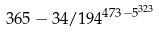Convert formula to latex. <formula><loc_0><loc_0><loc_500><loc_500>3 6 5 - 3 4 / 1 9 4 ^ { 4 7 3 - 5 ^ { 3 2 3 } }</formula> 